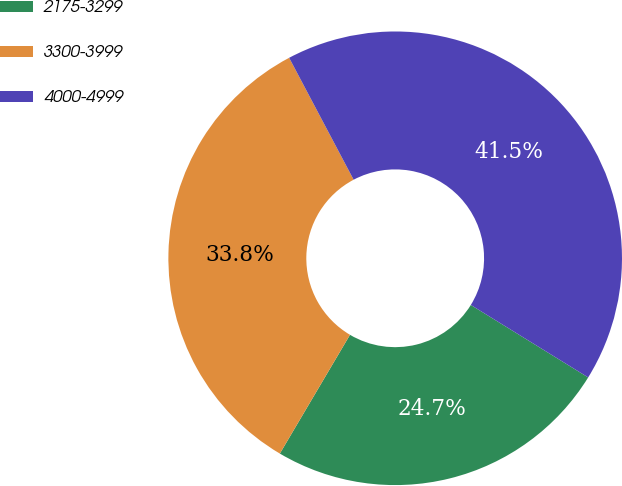Convert chart to OTSL. <chart><loc_0><loc_0><loc_500><loc_500><pie_chart><fcel>2175-3299<fcel>3300-3999<fcel>4000-4999<nl><fcel>24.69%<fcel>33.77%<fcel>41.55%<nl></chart> 